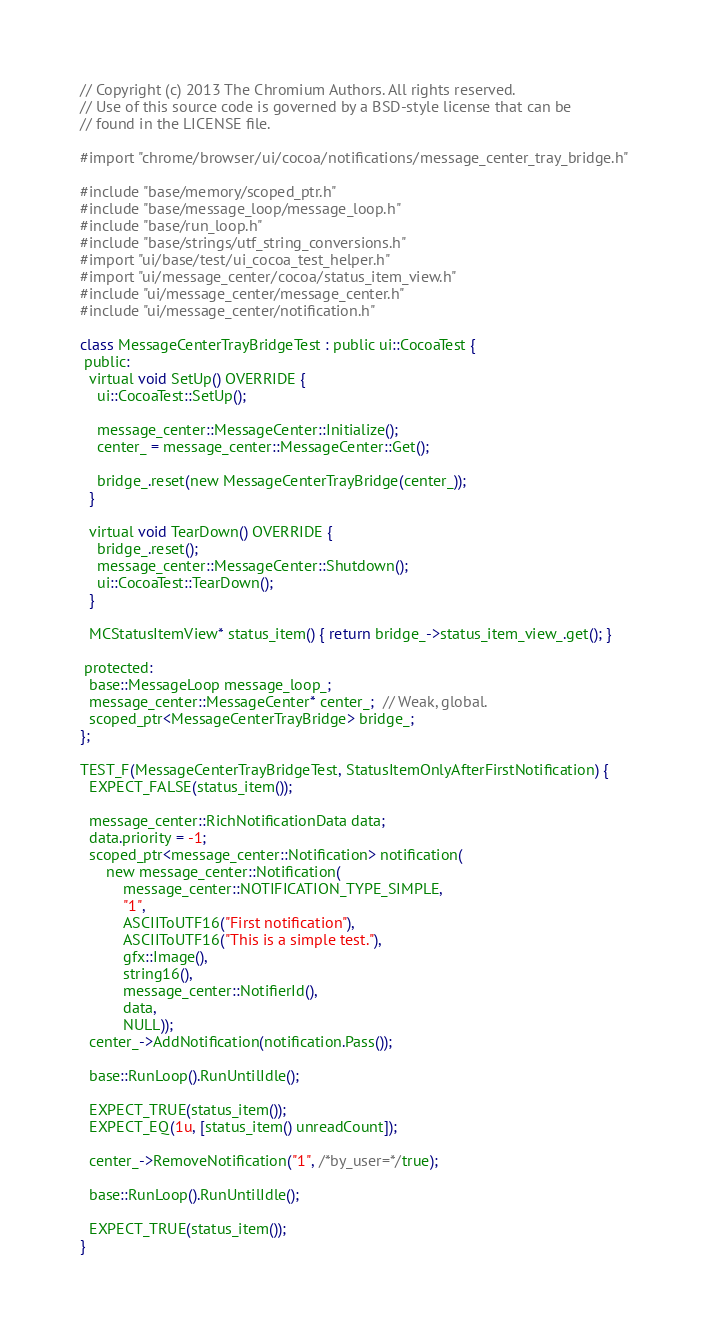Convert code to text. <code><loc_0><loc_0><loc_500><loc_500><_ObjectiveC_>// Copyright (c) 2013 The Chromium Authors. All rights reserved.
// Use of this source code is governed by a BSD-style license that can be
// found in the LICENSE file.

#import "chrome/browser/ui/cocoa/notifications/message_center_tray_bridge.h"

#include "base/memory/scoped_ptr.h"
#include "base/message_loop/message_loop.h"
#include "base/run_loop.h"
#include "base/strings/utf_string_conversions.h"
#import "ui/base/test/ui_cocoa_test_helper.h"
#import "ui/message_center/cocoa/status_item_view.h"
#include "ui/message_center/message_center.h"
#include "ui/message_center/notification.h"

class MessageCenterTrayBridgeTest : public ui::CocoaTest {
 public:
  virtual void SetUp() OVERRIDE {
    ui::CocoaTest::SetUp();

    message_center::MessageCenter::Initialize();
    center_ = message_center::MessageCenter::Get();

    bridge_.reset(new MessageCenterTrayBridge(center_));
  }

  virtual void TearDown() OVERRIDE {
    bridge_.reset();
    message_center::MessageCenter::Shutdown();
    ui::CocoaTest::TearDown();
  }

  MCStatusItemView* status_item() { return bridge_->status_item_view_.get(); }

 protected:
  base::MessageLoop message_loop_;
  message_center::MessageCenter* center_;  // Weak, global.
  scoped_ptr<MessageCenterTrayBridge> bridge_;
};

TEST_F(MessageCenterTrayBridgeTest, StatusItemOnlyAfterFirstNotification) {
  EXPECT_FALSE(status_item());

  message_center::RichNotificationData data;
  data.priority = -1;
  scoped_ptr<message_center::Notification> notification(
      new message_center::Notification(
          message_center::NOTIFICATION_TYPE_SIMPLE,
          "1",
          ASCIIToUTF16("First notification"),
          ASCIIToUTF16("This is a simple test."),
          gfx::Image(),
          string16(),
          message_center::NotifierId(),
          data,
          NULL));
  center_->AddNotification(notification.Pass());

  base::RunLoop().RunUntilIdle();

  EXPECT_TRUE(status_item());
  EXPECT_EQ(1u, [status_item() unreadCount]);

  center_->RemoveNotification("1", /*by_user=*/true);

  base::RunLoop().RunUntilIdle();

  EXPECT_TRUE(status_item());
}
</code> 